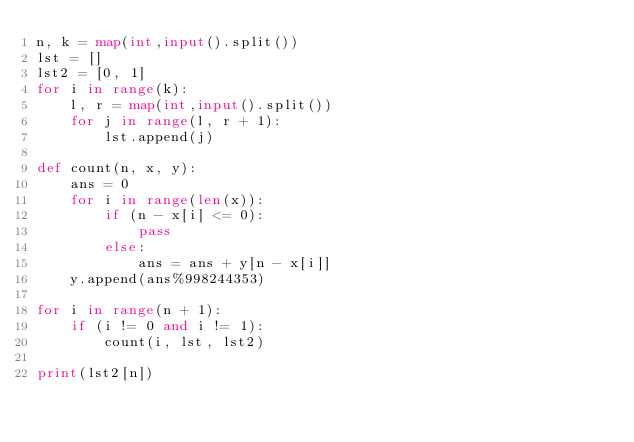<code> <loc_0><loc_0><loc_500><loc_500><_Python_>n, k = map(int,input().split())
lst = []
lst2 = [0, 1]
for i in range(k):
    l, r = map(int,input().split())
    for j in range(l, r + 1):
        lst.append(j)

def count(n, x, y):
    ans = 0
    for i in range(len(x)):
        if (n - x[i] <= 0):
            pass
        else:
            ans = ans + y[n - x[i]]
    y.append(ans%998244353)

for i in range(n + 1):
    if (i != 0 and i != 1):
        count(i, lst, lst2)

print(lst2[n])</code> 